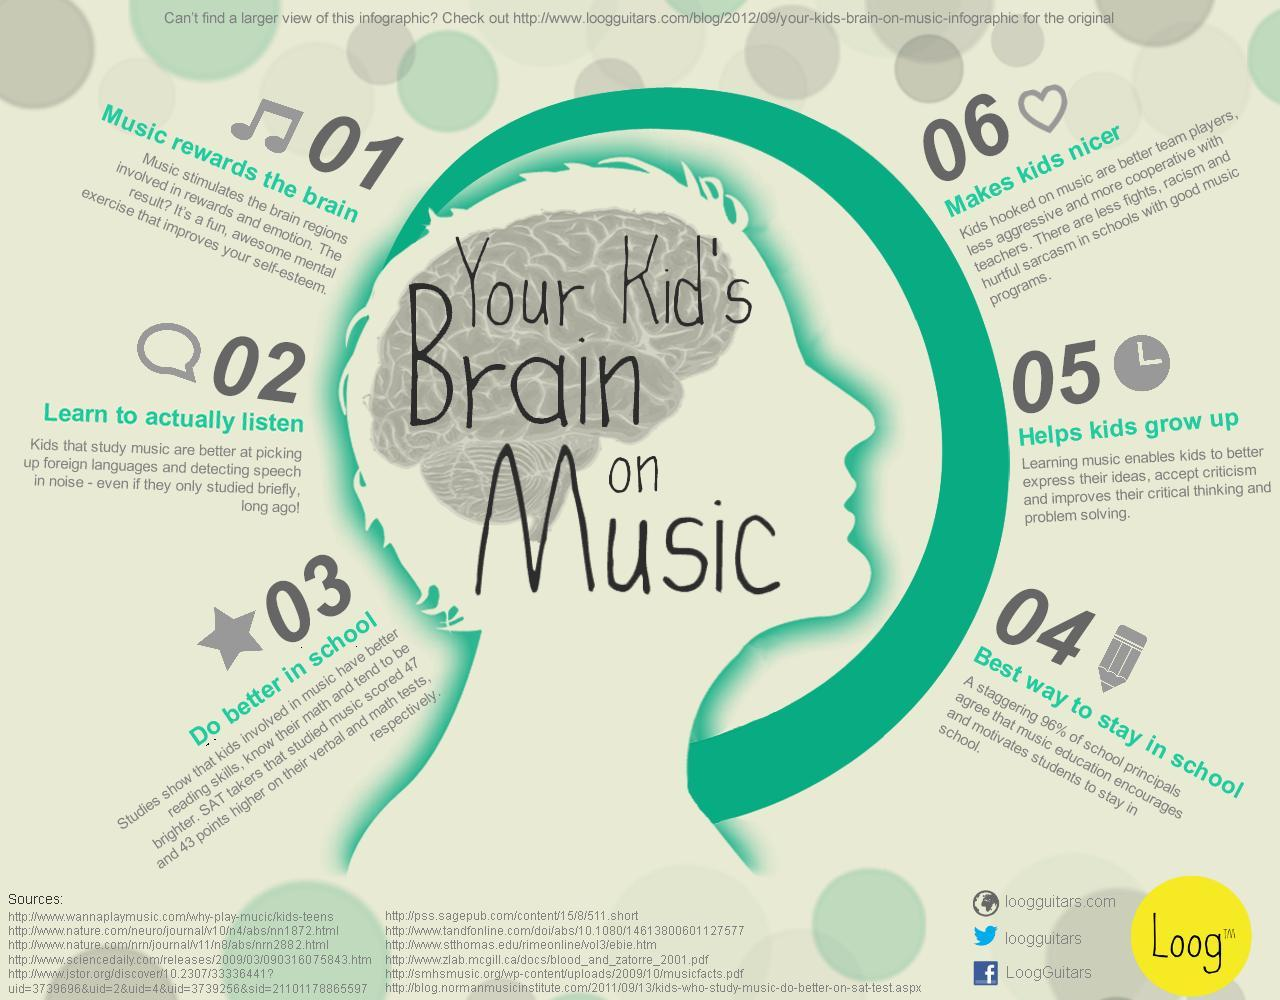What makes it easier for students at picking up foreign languages?
Answer the question with a short phrase. music How did SAT takers involved in music do in verbal and math tests? scored 47 and 43 points higher As per 1st point, what does music help to improve? self-esteem As per 5th point, which skills are improved by learning music? critical thinking and problem solving What motivates students to stay in school? music education 